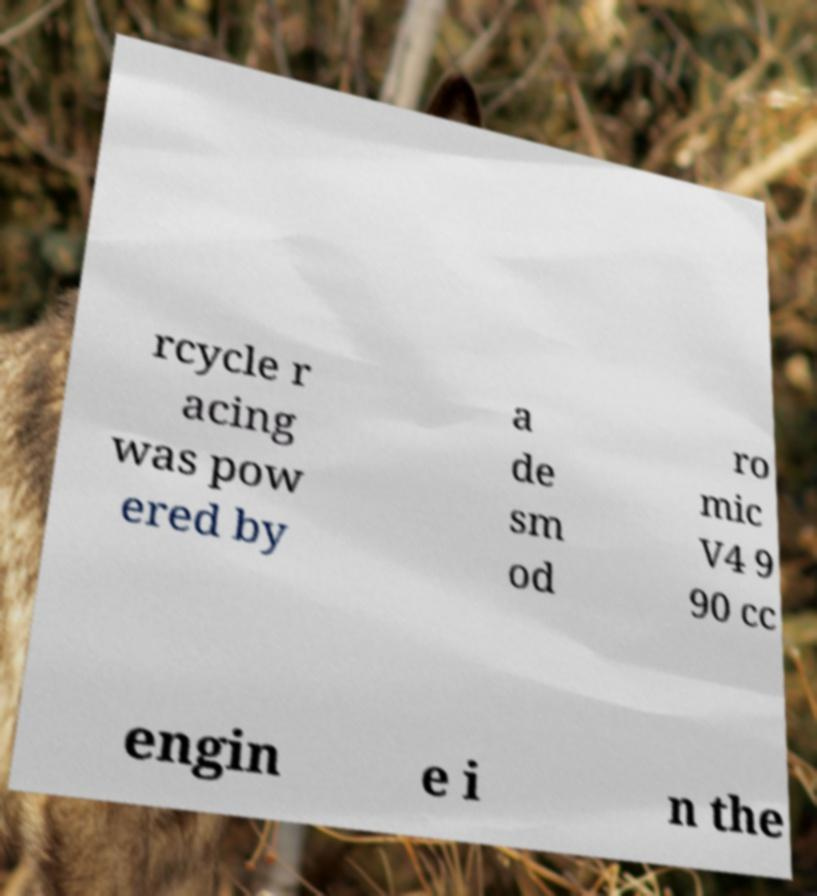I need the written content from this picture converted into text. Can you do that? rcycle r acing was pow ered by a de sm od ro mic V4 9 90 cc engin e i n the 